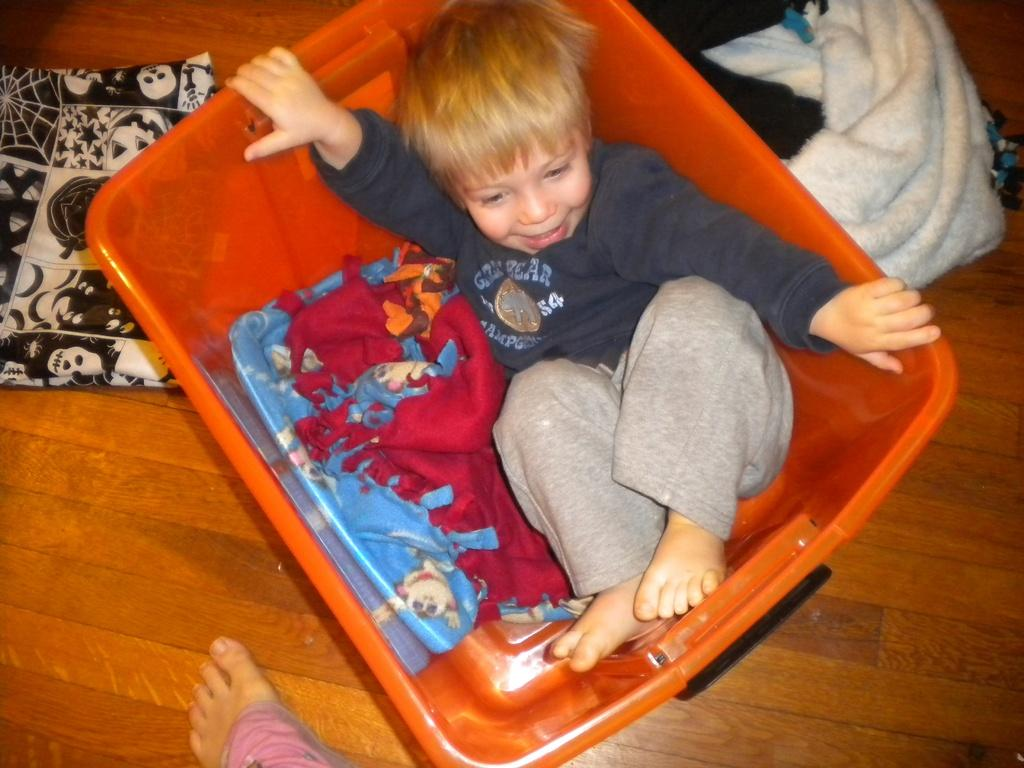What is the boy doing in the image? The boy is in a basket. What else can be seen on the floor in the image? There are clothes on the floor. What is in the basket with the boy? There is a cloth in the basket. Can you describe any body parts visible in the image? A human leg is visible in the image. What type of paint is being used to decorate the prison cell? There is no mention of paint or a prison cell in the provided facts, so we cannot answer this question. 